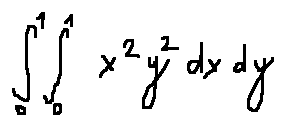Convert formula to latex. <formula><loc_0><loc_0><loc_500><loc_500>\int \lim i t s _ { 0 } ^ { 1 } \int \lim i t s _ { 0 } ^ { 1 } x ^ { 2 } y ^ { 2 } d x d y</formula> 